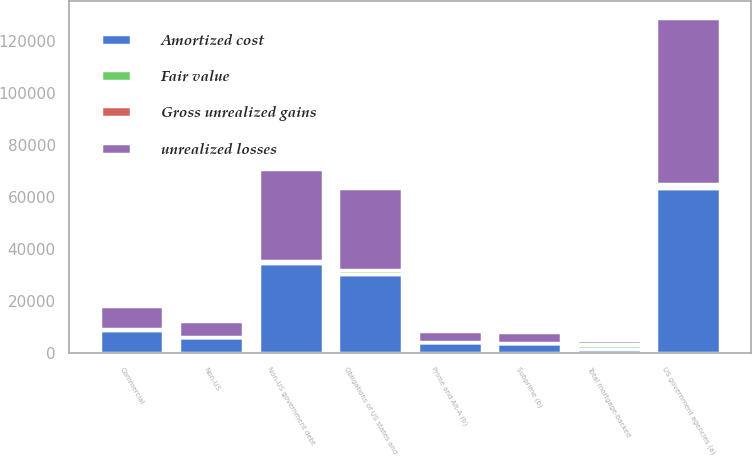Convert chart. <chart><loc_0><loc_0><loc_500><loc_500><stacked_bar_chart><ecel><fcel>US government agencies (a)<fcel>Prime and Alt-A (b)<fcel>Subprime (b)<fcel>Non-US<fcel>Commercial<fcel>Total mortgage-backed<fcel>Obligations of US states and<fcel>Non-US government debt<nl><fcel>Amortized cost<fcel>63367<fcel>4256<fcel>3915<fcel>6049<fcel>9002<fcel>1492<fcel>30284<fcel>34497<nl><fcel>Fair value<fcel>1112<fcel>38<fcel>62<fcel>158<fcel>122<fcel>1492<fcel>1492<fcel>836<nl><fcel>Gross unrealized gains<fcel>474<fcel>22<fcel>6<fcel>7<fcel>20<fcel>529<fcel>184<fcel>45<nl><fcel>unrealized losses<fcel>64005<fcel>4272<fcel>3971<fcel>6200<fcel>9104<fcel>1492<fcel>31592<fcel>35288<nl></chart> 